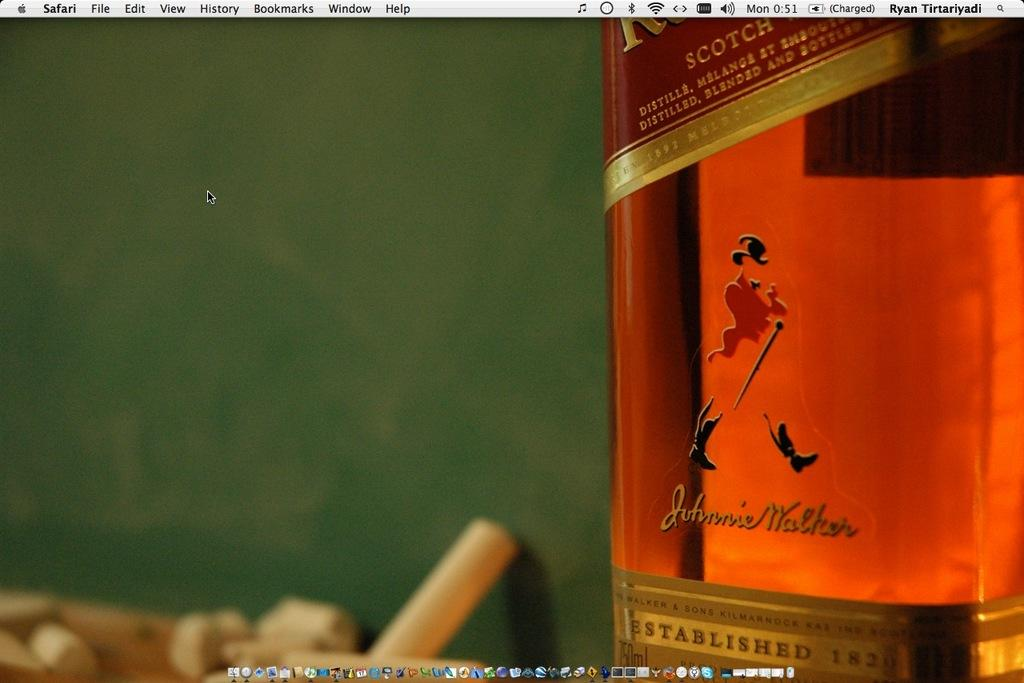<image>
Give a short and clear explanation of the subsequent image. A bottle of Johnnie Walker scotch in front of a chalkboard. 